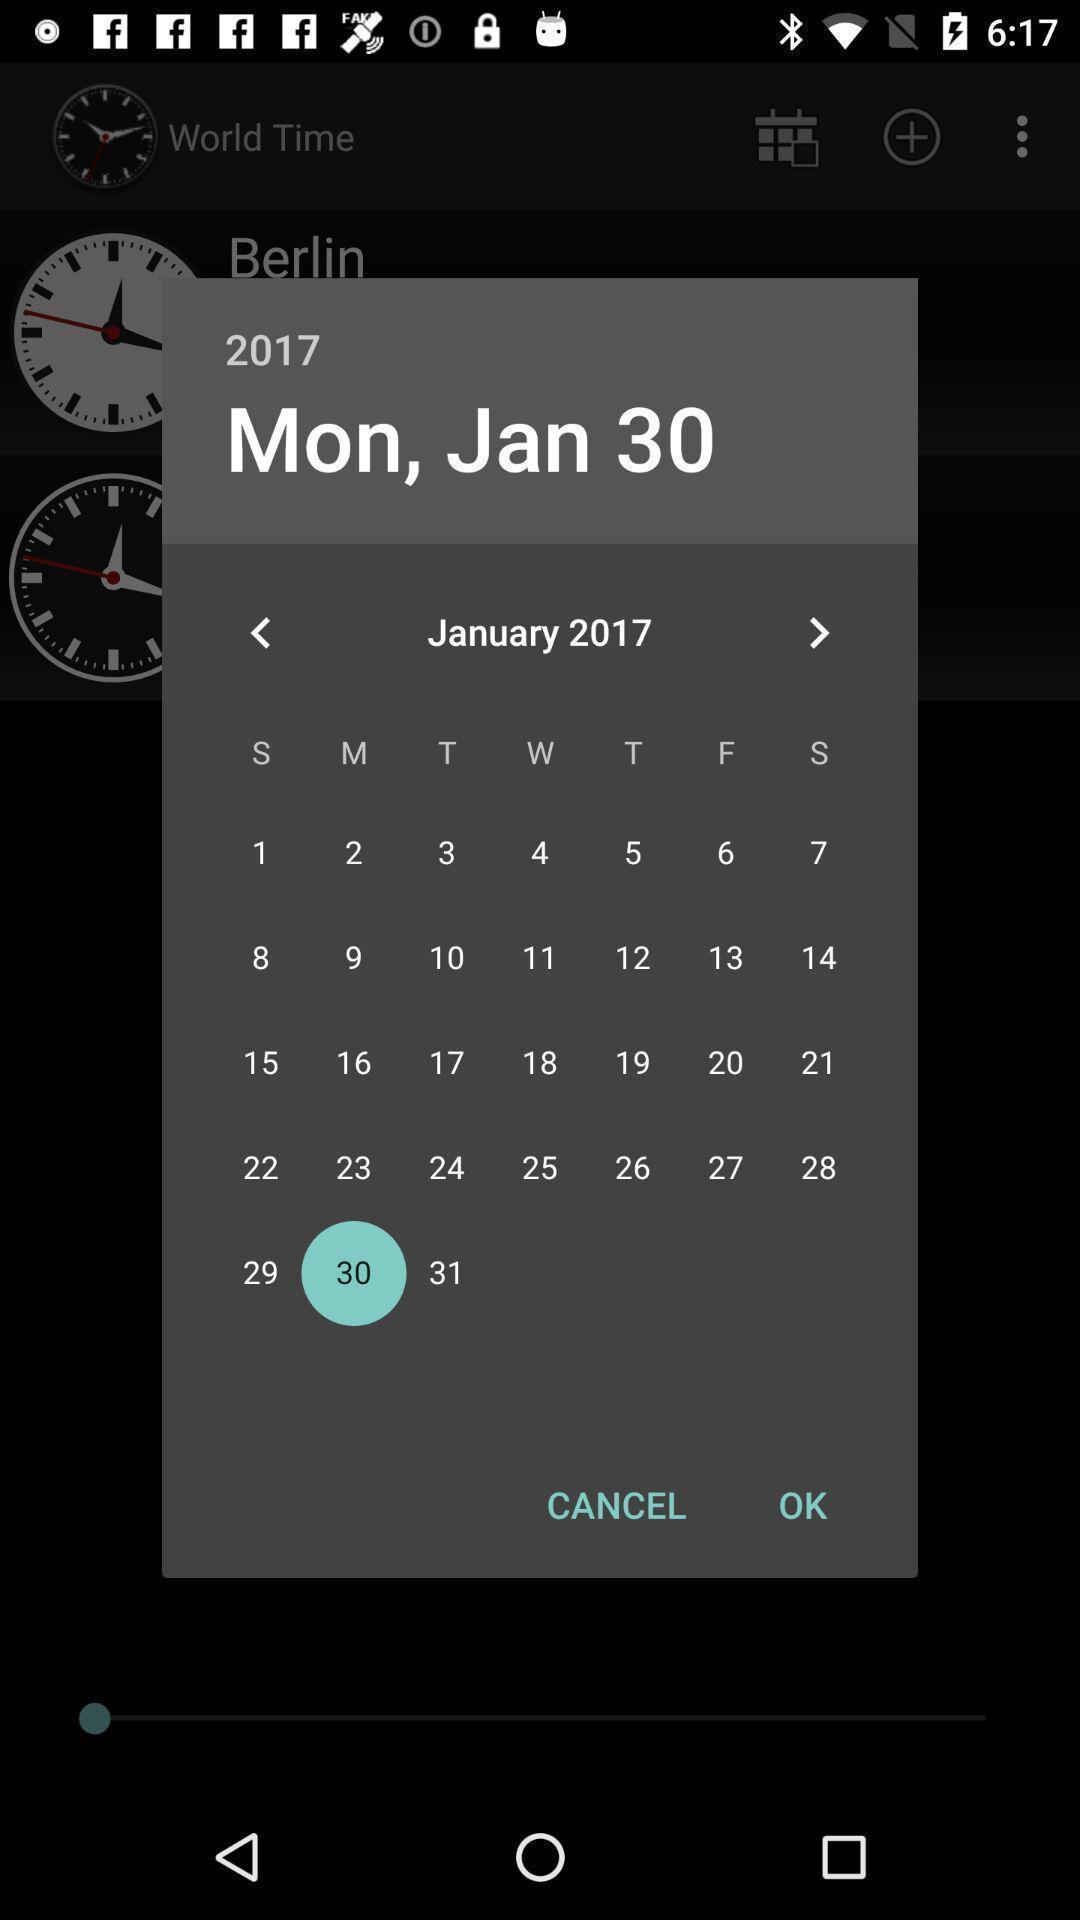Tell me what you see in this picture. Popup displaying calendar information about an application. 